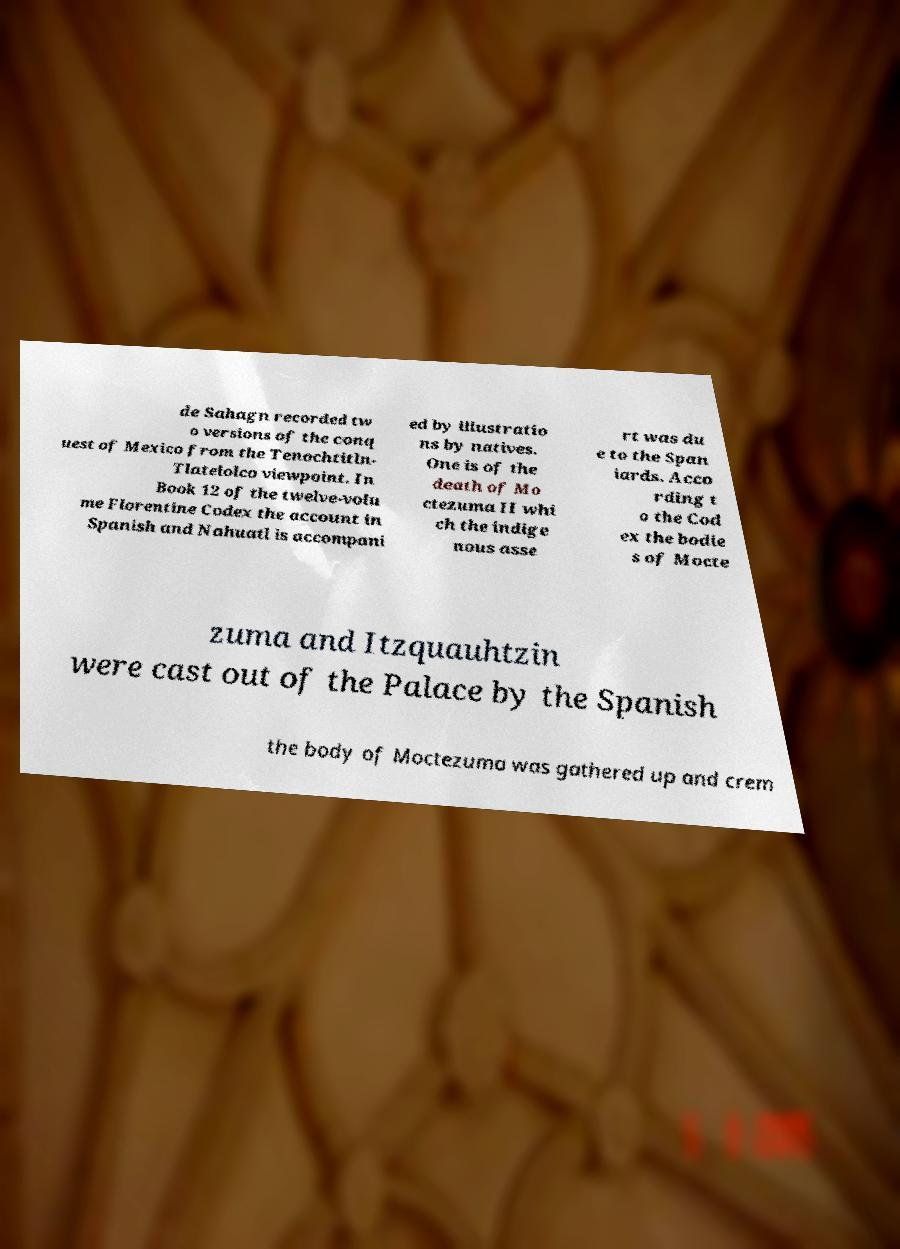There's text embedded in this image that I need extracted. Can you transcribe it verbatim? de Sahagn recorded tw o versions of the conq uest of Mexico from the Tenochtitln- Tlatelolco viewpoint. In Book 12 of the twelve-volu me Florentine Codex the account in Spanish and Nahuatl is accompani ed by illustratio ns by natives. One is of the death of Mo ctezuma II whi ch the indige nous asse rt was du e to the Span iards. Acco rding t o the Cod ex the bodie s of Mocte zuma and Itzquauhtzin were cast out of the Palace by the Spanish the body of Moctezuma was gathered up and crem 